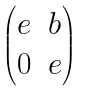<formula> <loc_0><loc_0><loc_500><loc_500>\begin{pmatrix} e & b \\ 0 & e \end{pmatrix}</formula> 